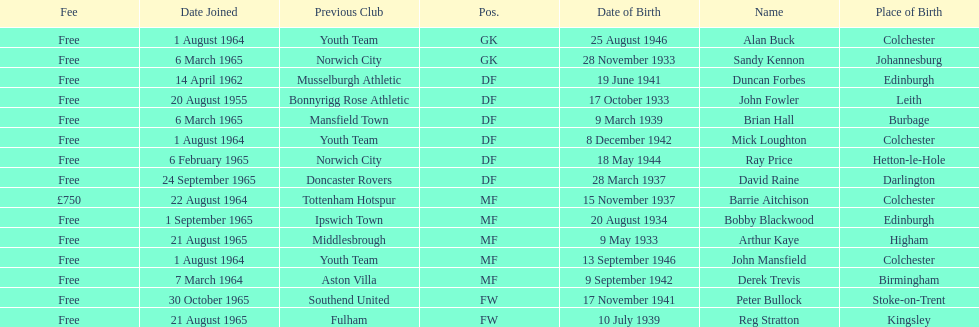What is the other fee listed, besides free? £750. Would you be able to parse every entry in this table? {'header': ['Fee', 'Date Joined', 'Previous Club', 'Pos.', 'Date of Birth', 'Name', 'Place of Birth'], 'rows': [['Free', '1 August 1964', 'Youth Team', 'GK', '25 August 1946', 'Alan Buck', 'Colchester'], ['Free', '6 March 1965', 'Norwich City', 'GK', '28 November 1933', 'Sandy Kennon', 'Johannesburg'], ['Free', '14 April 1962', 'Musselburgh Athletic', 'DF', '19 June 1941', 'Duncan Forbes', 'Edinburgh'], ['Free', '20 August 1955', 'Bonnyrigg Rose Athletic', 'DF', '17 October 1933', 'John Fowler', 'Leith'], ['Free', '6 March 1965', 'Mansfield Town', 'DF', '9 March 1939', 'Brian Hall', 'Burbage'], ['Free', '1 August 1964', 'Youth Team', 'DF', '8 December 1942', 'Mick Loughton', 'Colchester'], ['Free', '6 February 1965', 'Norwich City', 'DF', '18 May 1944', 'Ray Price', 'Hetton-le-Hole'], ['Free', '24 September 1965', 'Doncaster Rovers', 'DF', '28 March 1937', 'David Raine', 'Darlington'], ['£750', '22 August 1964', 'Tottenham Hotspur', 'MF', '15 November 1937', 'Barrie Aitchison', 'Colchester'], ['Free', '1 September 1965', 'Ipswich Town', 'MF', '20 August 1934', 'Bobby Blackwood', 'Edinburgh'], ['Free', '21 August 1965', 'Middlesbrough', 'MF', '9 May 1933', 'Arthur Kaye', 'Higham'], ['Free', '1 August 1964', 'Youth Team', 'MF', '13 September 1946', 'John Mansfield', 'Colchester'], ['Free', '7 March 1964', 'Aston Villa', 'MF', '9 September 1942', 'Derek Trevis', 'Birmingham'], ['Free', '30 October 1965', 'Southend United', 'FW', '17 November 1941', 'Peter Bullock', 'Stoke-on-Trent'], ['Free', '21 August 1965', 'Fulham', 'FW', '10 July 1939', 'Reg Stratton', 'Kingsley']]} 